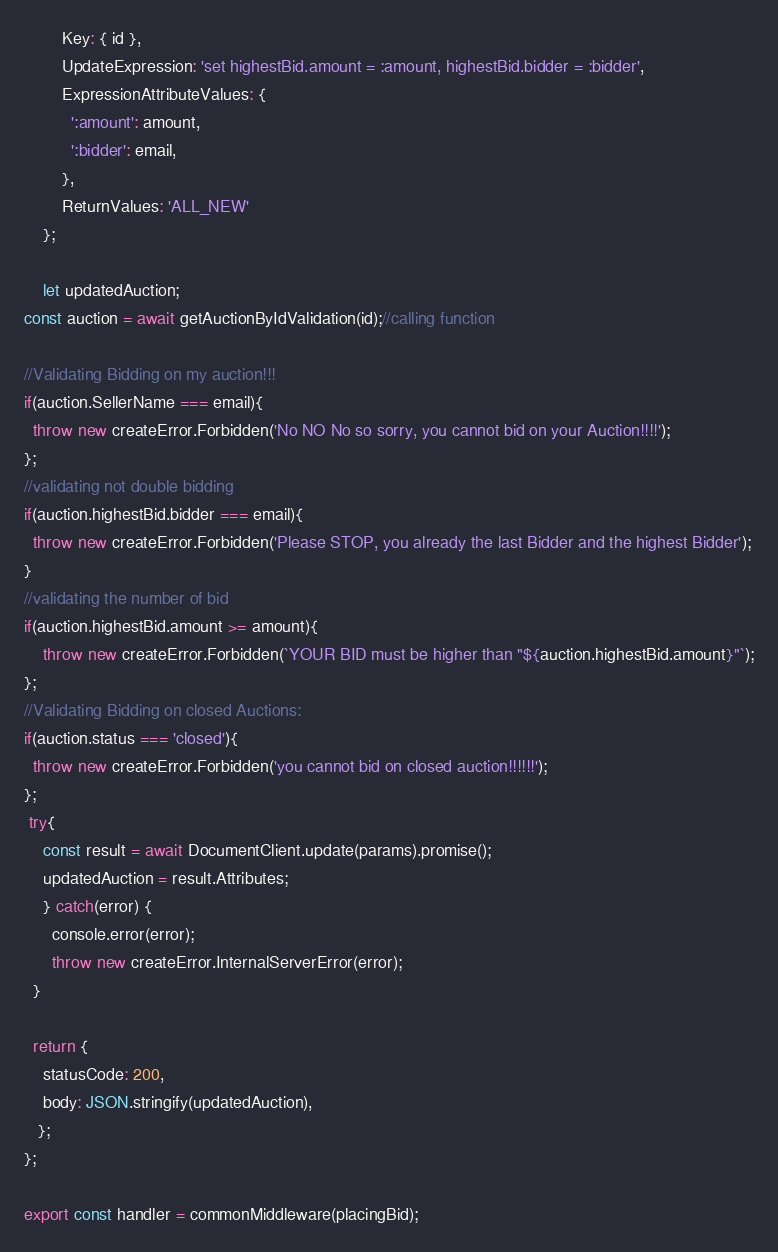<code> <loc_0><loc_0><loc_500><loc_500><_JavaScript_>        Key: { id },
        UpdateExpression: 'set highestBid.amount = :amount, highestBid.bidder = :bidder',
        ExpressionAttributeValues: {
          ':amount': amount,
          ':bidder': email,
        },
        ReturnValues: 'ALL_NEW'
    };

    let updatedAuction;
const auction = await getAuctionByIdValidation(id);//calling function

//Validating Bidding on my auction!!!
if(auction.SellerName === email){
  throw new createError.Forbidden('No NO No so sorry, you cannot bid on your Auction!!!!');
};
//validating not double bidding
if(auction.highestBid.bidder === email){
  throw new createError.Forbidden('Please STOP, you already the last Bidder and the highest Bidder');
}
//validating the number of bid
if(auction.highestBid.amount >= amount){
    throw new createError.Forbidden(`YOUR BID must be higher than "${auction.highestBid.amount}"`);
};
//Validating Bidding on closed Auctions:
if(auction.status === 'closed'){
  throw new createError.Forbidden('you cannot bid on closed auction!!!!!!');
};
 try{
    const result = await DocumentClient.update(params).promise();
    updatedAuction = result.Attributes;
    } catch(error) {
      console.error(error);
      throw new createError.InternalServerError(error);
  }

  return {
    statusCode: 200,
    body: JSON.stringify(updatedAuction),
   };
};

export const handler = commonMiddleware(placingBid);
</code> 